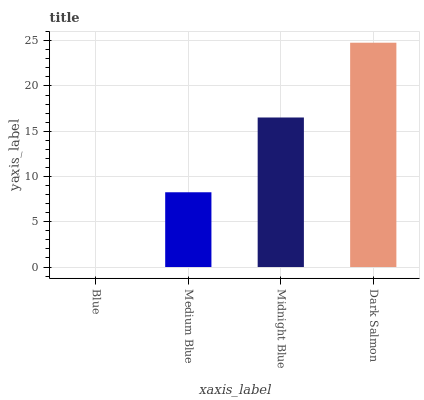Is Blue the minimum?
Answer yes or no. Yes. Is Dark Salmon the maximum?
Answer yes or no. Yes. Is Medium Blue the minimum?
Answer yes or no. No. Is Medium Blue the maximum?
Answer yes or no. No. Is Medium Blue greater than Blue?
Answer yes or no. Yes. Is Blue less than Medium Blue?
Answer yes or no. Yes. Is Blue greater than Medium Blue?
Answer yes or no. No. Is Medium Blue less than Blue?
Answer yes or no. No. Is Midnight Blue the high median?
Answer yes or no. Yes. Is Medium Blue the low median?
Answer yes or no. Yes. Is Blue the high median?
Answer yes or no. No. Is Midnight Blue the low median?
Answer yes or no. No. 